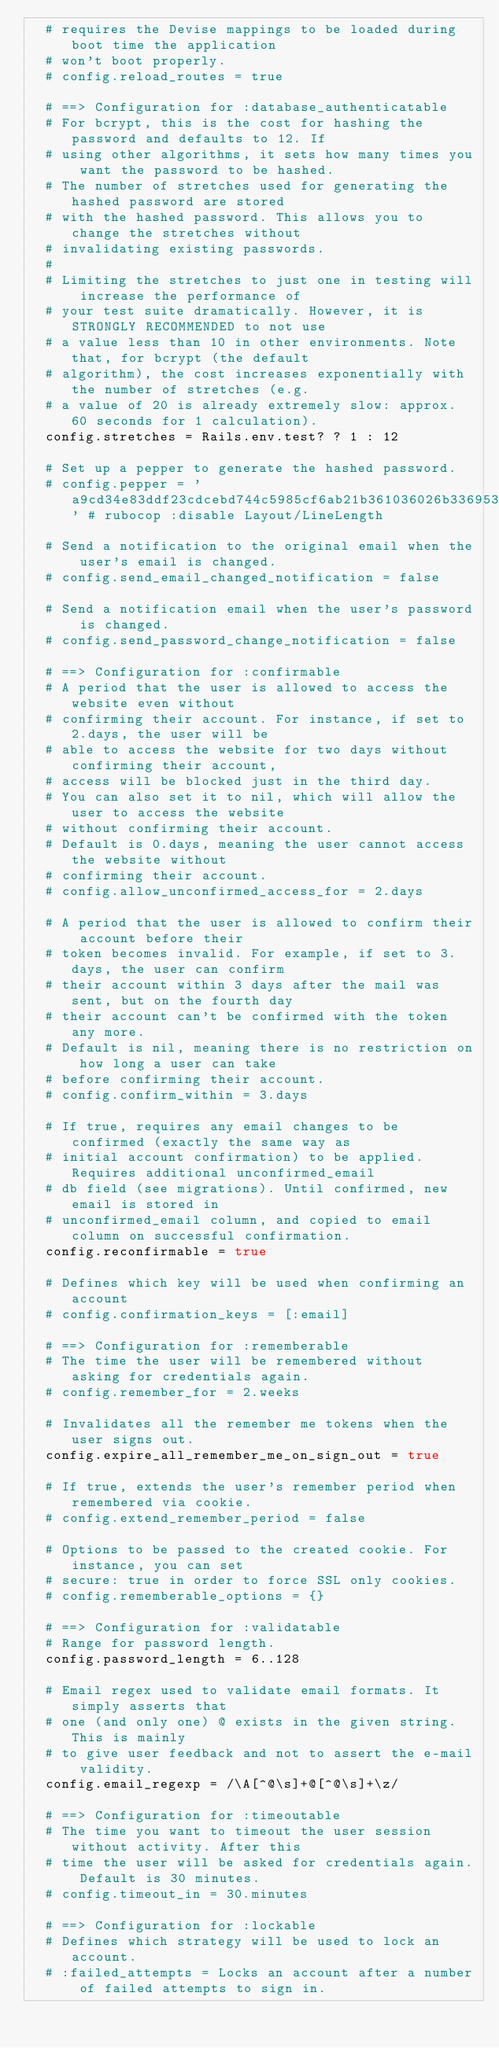Convert code to text. <code><loc_0><loc_0><loc_500><loc_500><_Ruby_>  # requires the Devise mappings to be loaded during boot time the application
  # won't boot properly.
  # config.reload_routes = true

  # ==> Configuration for :database_authenticatable
  # For bcrypt, this is the cost for hashing the password and defaults to 12. If
  # using other algorithms, it sets how many times you want the password to be hashed.
  # The number of stretches used for generating the hashed password are stored
  # with the hashed password. This allows you to change the stretches without
  # invalidating existing passwords.
  #
  # Limiting the stretches to just one in testing will increase the performance of
  # your test suite dramatically. However, it is STRONGLY RECOMMENDED to not use
  # a value less than 10 in other environments. Note that, for bcrypt (the default
  # algorithm), the cost increases exponentially with the number of stretches (e.g.
  # a value of 20 is already extremely slow: approx. 60 seconds for 1 calculation).
  config.stretches = Rails.env.test? ? 1 : 12

  # Set up a pepper to generate the hashed password.
  # config.pepper = 'a9cd34e83ddf23cdcebd744c5985cf6ab21b361036026b336953a57be69d8589de2466bcef0d433fb85ba249e5185ff2950fd21aef42663642389839d66c7ee3' # rubocop :disable Layout/LineLength

  # Send a notification to the original email when the user's email is changed.
  # config.send_email_changed_notification = false

  # Send a notification email when the user's password is changed.
  # config.send_password_change_notification = false

  # ==> Configuration for :confirmable
  # A period that the user is allowed to access the website even without
  # confirming their account. For instance, if set to 2.days, the user will be
  # able to access the website for two days without confirming their account,
  # access will be blocked just in the third day.
  # You can also set it to nil, which will allow the user to access the website
  # without confirming their account.
  # Default is 0.days, meaning the user cannot access the website without
  # confirming their account.
  # config.allow_unconfirmed_access_for = 2.days

  # A period that the user is allowed to confirm their account before their
  # token becomes invalid. For example, if set to 3.days, the user can confirm
  # their account within 3 days after the mail was sent, but on the fourth day
  # their account can't be confirmed with the token any more.
  # Default is nil, meaning there is no restriction on how long a user can take
  # before confirming their account.
  # config.confirm_within = 3.days

  # If true, requires any email changes to be confirmed (exactly the same way as
  # initial account confirmation) to be applied. Requires additional unconfirmed_email
  # db field (see migrations). Until confirmed, new email is stored in
  # unconfirmed_email column, and copied to email column on successful confirmation.
  config.reconfirmable = true

  # Defines which key will be used when confirming an account
  # config.confirmation_keys = [:email]

  # ==> Configuration for :rememberable
  # The time the user will be remembered without asking for credentials again.
  # config.remember_for = 2.weeks

  # Invalidates all the remember me tokens when the user signs out.
  config.expire_all_remember_me_on_sign_out = true

  # If true, extends the user's remember period when remembered via cookie.
  # config.extend_remember_period = false

  # Options to be passed to the created cookie. For instance, you can set
  # secure: true in order to force SSL only cookies.
  # config.rememberable_options = {}

  # ==> Configuration for :validatable
  # Range for password length.
  config.password_length = 6..128

  # Email regex used to validate email formats. It simply asserts that
  # one (and only one) @ exists in the given string. This is mainly
  # to give user feedback and not to assert the e-mail validity.
  config.email_regexp = /\A[^@\s]+@[^@\s]+\z/

  # ==> Configuration for :timeoutable
  # The time you want to timeout the user session without activity. After this
  # time the user will be asked for credentials again. Default is 30 minutes.
  # config.timeout_in = 30.minutes

  # ==> Configuration for :lockable
  # Defines which strategy will be used to lock an account.
  # :failed_attempts = Locks an account after a number of failed attempts to sign in.</code> 